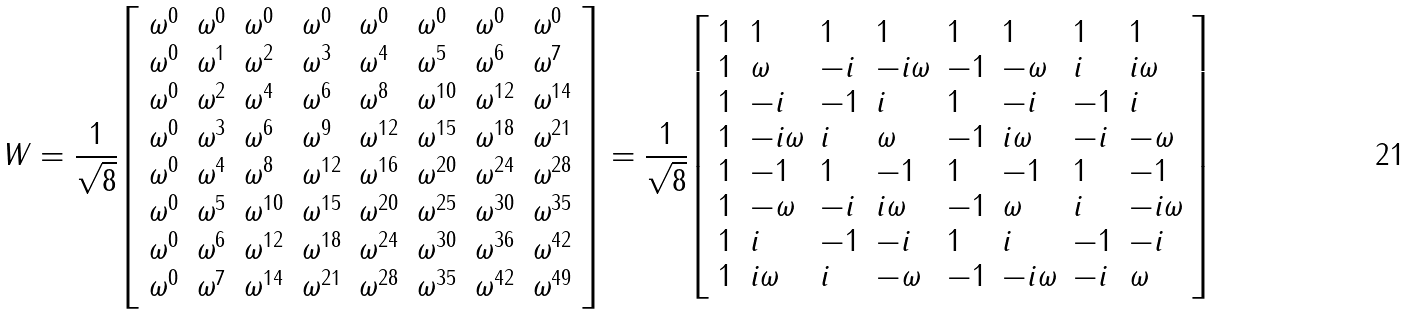<formula> <loc_0><loc_0><loc_500><loc_500>W = { \frac { 1 } { \sqrt { 8 } } } { \left [ \begin{array} { l l l l l l l l } { \omega ^ { 0 } } & { \omega ^ { 0 } } & { \omega ^ { 0 } } & { \omega ^ { 0 } } & { \omega ^ { 0 } } & { \omega ^ { 0 } } & { \omega ^ { 0 } } & { \omega ^ { 0 } } \\ { \omega ^ { 0 } } & { \omega ^ { 1 } } & { \omega ^ { 2 } } & { \omega ^ { 3 } } & { \omega ^ { 4 } } & { \omega ^ { 5 } } & { \omega ^ { 6 } } & { \omega ^ { 7 } } \\ { \omega ^ { 0 } } & { \omega ^ { 2 } } & { \omega ^ { 4 } } & { \omega ^ { 6 } } & { \omega ^ { 8 } } & { \omega ^ { 1 0 } } & { \omega ^ { 1 2 } } & { \omega ^ { 1 4 } } \\ { \omega ^ { 0 } } & { \omega ^ { 3 } } & { \omega ^ { 6 } } & { \omega ^ { 9 } } & { \omega ^ { 1 2 } } & { \omega ^ { 1 5 } } & { \omega ^ { 1 8 } } & { \omega ^ { 2 1 } } \\ { \omega ^ { 0 } } & { \omega ^ { 4 } } & { \omega ^ { 8 } } & { \omega ^ { 1 2 } } & { \omega ^ { 1 6 } } & { \omega ^ { 2 0 } } & { \omega ^ { 2 4 } } & { \omega ^ { 2 8 } } \\ { \omega ^ { 0 } } & { \omega ^ { 5 } } & { \omega ^ { 1 0 } } & { \omega ^ { 1 5 } } & { \omega ^ { 2 0 } } & { \omega ^ { 2 5 } } & { \omega ^ { 3 0 } } & { \omega ^ { 3 5 } } \\ { \omega ^ { 0 } } & { \omega ^ { 6 } } & { \omega ^ { 1 2 } } & { \omega ^ { 1 8 } } & { \omega ^ { 2 4 } } & { \omega ^ { 3 0 } } & { \omega ^ { 3 6 } } & { \omega ^ { 4 2 } } \\ { \omega ^ { 0 } } & { \omega ^ { 7 } } & { \omega ^ { 1 4 } } & { \omega ^ { 2 1 } } & { \omega ^ { 2 8 } } & { \omega ^ { 3 5 } } & { \omega ^ { 4 2 } } & { \omega ^ { 4 9 } } \end{array} \right ] } = { \frac { 1 } { \sqrt { 8 } } } { \left [ \begin{array} { l l l l l l l l } { 1 } & { 1 } & { 1 } & { 1 } & { 1 } & { 1 } & { 1 } & { 1 } \\ { 1 } & { \omega } & { - i } & { - i \omega } & { - 1 } & { - \omega } & { i } & { i \omega } \\ { 1 } & { - i } & { - 1 } & { i } & { 1 } & { - i } & { - 1 } & { i } \\ { 1 } & { - i \omega } & { i } & { \omega } & { - 1 } & { i \omega } & { - i } & { - \omega } \\ { 1 } & { - 1 } & { 1 } & { - 1 } & { 1 } & { - 1 } & { 1 } & { - 1 } \\ { 1 } & { - \omega } & { - i } & { i \omega } & { - 1 } & { \omega } & { i } & { - i \omega } \\ { 1 } & { i } & { - 1 } & { - i } & { 1 } & { i } & { - 1 } & { - i } \\ { 1 } & { i \omega } & { i } & { - \omega } & { - 1 } & { - i \omega } & { - i } & { \omega } \end{array} \right ] }</formula> 